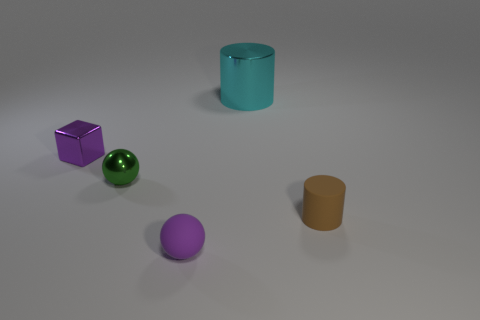Add 5 purple blocks. How many objects exist? 10 Subtract all blocks. How many objects are left? 4 Add 4 small cyan metallic cylinders. How many small cyan metallic cylinders exist? 4 Subtract 1 green balls. How many objects are left? 4 Subtract all big green cubes. Subtract all green shiny objects. How many objects are left? 4 Add 5 purple rubber spheres. How many purple rubber spheres are left? 6 